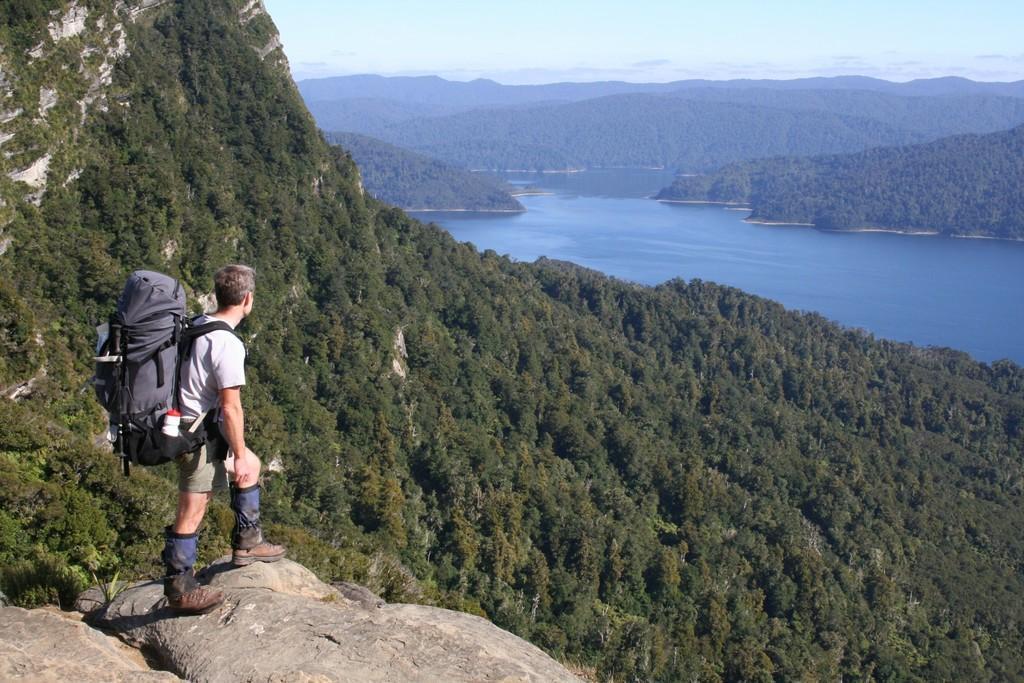Could you give a brief overview of what you see in this image? In a given image we can see a man standing with bag on his back, he is wearing shoes. There are many trees and a river. 